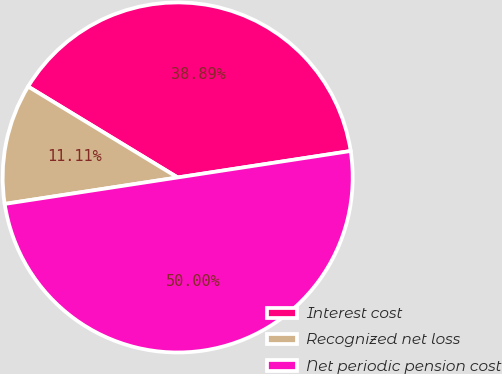Convert chart. <chart><loc_0><loc_0><loc_500><loc_500><pie_chart><fcel>Interest cost<fcel>Recognized net loss<fcel>Net periodic pension cost<nl><fcel>38.89%<fcel>11.11%<fcel>50.0%<nl></chart> 